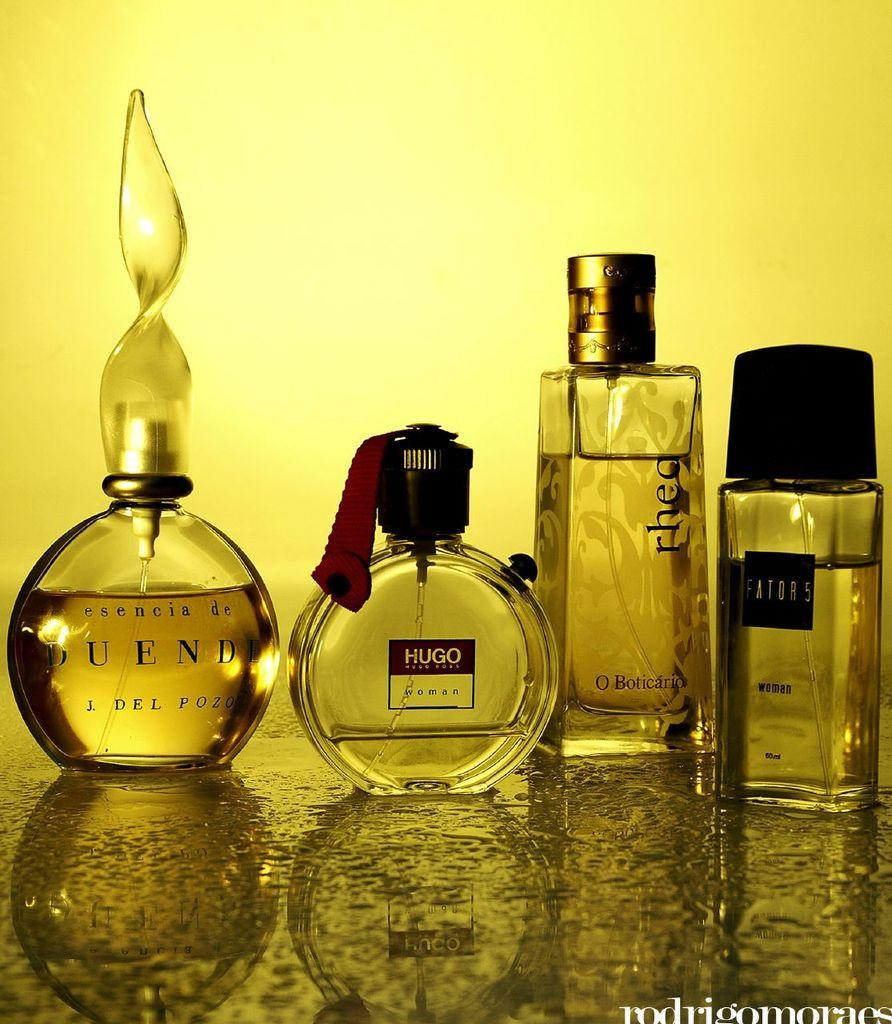Provide a one-sentence caption for the provided image. Different bottles of perfume and cologne one of which is by Hugo. 